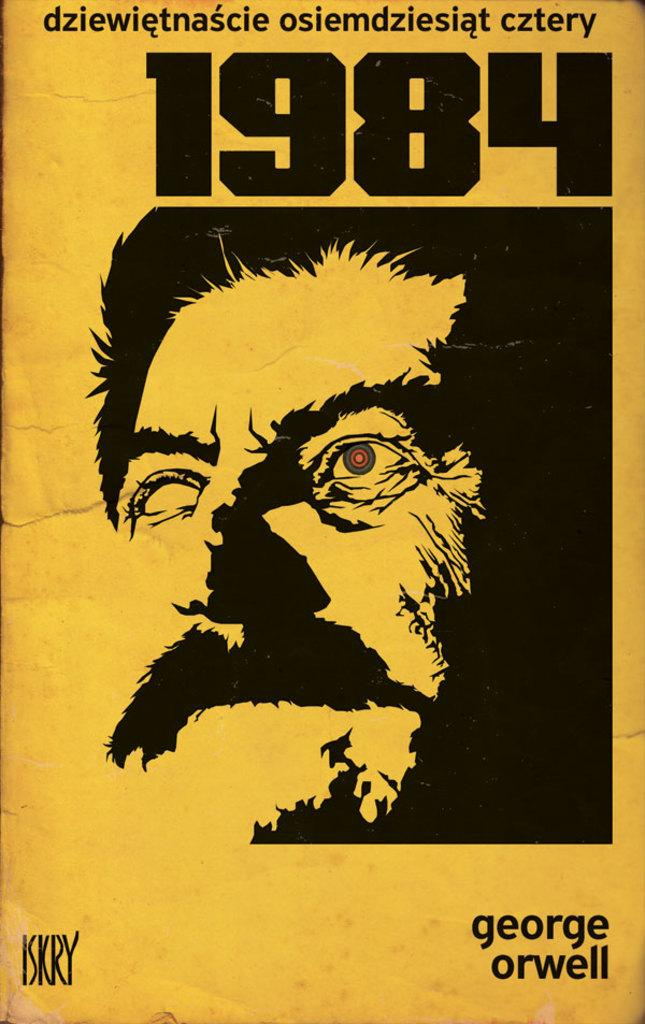<image>
Render a clear and concise summary of the photo. A book cover of George Orwell's 1984 with an image of a man on it. 